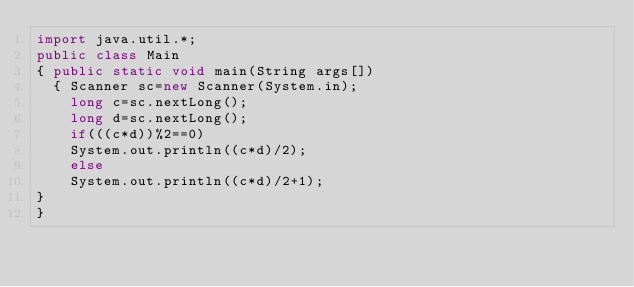<code> <loc_0><loc_0><loc_500><loc_500><_Java_>import java.util.*;
public class Main
{ public static void main(String args[])
  { Scanner sc=new Scanner(System.in);
    long c=sc.nextLong();
    long d=sc.nextLong();
    if(((c*d))%2==0)
    System.out.println((c*d)/2);
    else
    System.out.println((c*d)/2+1);
}
}</code> 